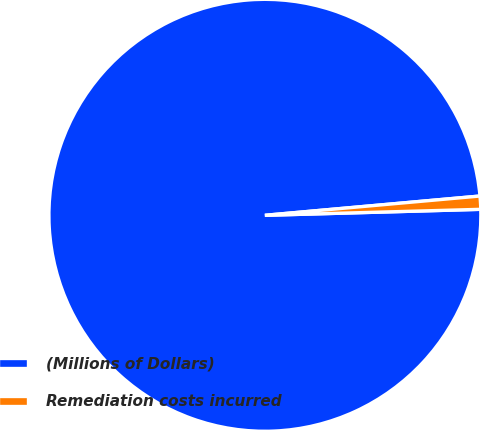Convert chart to OTSL. <chart><loc_0><loc_0><loc_500><loc_500><pie_chart><fcel>(Millions of Dollars)<fcel>Remediation costs incurred<nl><fcel>99.02%<fcel>0.98%<nl></chart> 